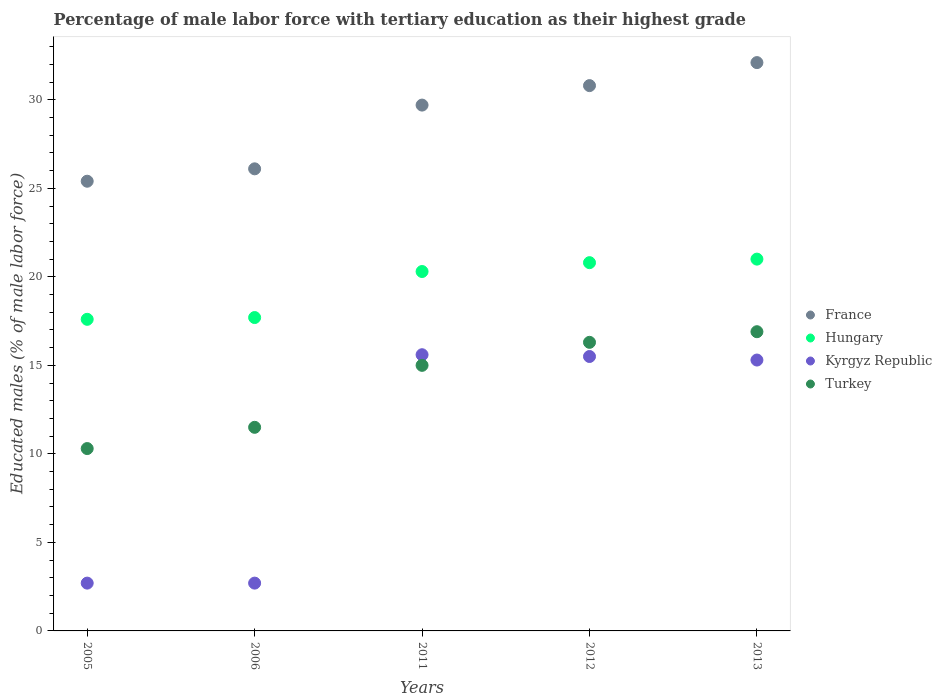What is the percentage of male labor force with tertiary education in France in 2012?
Your response must be concise. 30.8. Across all years, what is the maximum percentage of male labor force with tertiary education in Kyrgyz Republic?
Make the answer very short. 15.6. Across all years, what is the minimum percentage of male labor force with tertiary education in Turkey?
Make the answer very short. 10.3. In which year was the percentage of male labor force with tertiary education in Kyrgyz Republic maximum?
Your response must be concise. 2011. What is the total percentage of male labor force with tertiary education in Hungary in the graph?
Your answer should be very brief. 97.4. What is the difference between the percentage of male labor force with tertiary education in Hungary in 2013 and the percentage of male labor force with tertiary education in Turkey in 2005?
Ensure brevity in your answer.  10.7. What is the average percentage of male labor force with tertiary education in France per year?
Your answer should be very brief. 28.82. In the year 2005, what is the difference between the percentage of male labor force with tertiary education in Hungary and percentage of male labor force with tertiary education in France?
Your answer should be very brief. -7.8. What is the ratio of the percentage of male labor force with tertiary education in Turkey in 2005 to that in 2011?
Give a very brief answer. 0.69. What is the difference between the highest and the second highest percentage of male labor force with tertiary education in Hungary?
Ensure brevity in your answer.  0.2. What is the difference between the highest and the lowest percentage of male labor force with tertiary education in Kyrgyz Republic?
Provide a succinct answer. 12.9. In how many years, is the percentage of male labor force with tertiary education in Hungary greater than the average percentage of male labor force with tertiary education in Hungary taken over all years?
Your answer should be compact. 3. Is the sum of the percentage of male labor force with tertiary education in Kyrgyz Republic in 2005 and 2012 greater than the maximum percentage of male labor force with tertiary education in Turkey across all years?
Provide a short and direct response. Yes. Is it the case that in every year, the sum of the percentage of male labor force with tertiary education in Kyrgyz Republic and percentage of male labor force with tertiary education in Hungary  is greater than the percentage of male labor force with tertiary education in Turkey?
Keep it short and to the point. Yes. Is the percentage of male labor force with tertiary education in France strictly less than the percentage of male labor force with tertiary education in Kyrgyz Republic over the years?
Make the answer very short. No. How many years are there in the graph?
Offer a very short reply. 5. What is the difference between two consecutive major ticks on the Y-axis?
Offer a very short reply. 5. Are the values on the major ticks of Y-axis written in scientific E-notation?
Make the answer very short. No. Does the graph contain any zero values?
Your answer should be very brief. No. Does the graph contain grids?
Provide a succinct answer. No. How many legend labels are there?
Ensure brevity in your answer.  4. How are the legend labels stacked?
Provide a short and direct response. Vertical. What is the title of the graph?
Your answer should be compact. Percentage of male labor force with tertiary education as their highest grade. What is the label or title of the X-axis?
Give a very brief answer. Years. What is the label or title of the Y-axis?
Offer a very short reply. Educated males (% of male labor force). What is the Educated males (% of male labor force) in France in 2005?
Your response must be concise. 25.4. What is the Educated males (% of male labor force) of Hungary in 2005?
Offer a terse response. 17.6. What is the Educated males (% of male labor force) of Kyrgyz Republic in 2005?
Your answer should be very brief. 2.7. What is the Educated males (% of male labor force) of Turkey in 2005?
Keep it short and to the point. 10.3. What is the Educated males (% of male labor force) in France in 2006?
Make the answer very short. 26.1. What is the Educated males (% of male labor force) of Hungary in 2006?
Ensure brevity in your answer.  17.7. What is the Educated males (% of male labor force) of Kyrgyz Republic in 2006?
Make the answer very short. 2.7. What is the Educated males (% of male labor force) in France in 2011?
Ensure brevity in your answer.  29.7. What is the Educated males (% of male labor force) in Hungary in 2011?
Ensure brevity in your answer.  20.3. What is the Educated males (% of male labor force) of Kyrgyz Republic in 2011?
Ensure brevity in your answer.  15.6. What is the Educated males (% of male labor force) in France in 2012?
Provide a short and direct response. 30.8. What is the Educated males (% of male labor force) in Hungary in 2012?
Offer a terse response. 20.8. What is the Educated males (% of male labor force) of Kyrgyz Republic in 2012?
Ensure brevity in your answer.  15.5. What is the Educated males (% of male labor force) of Turkey in 2012?
Give a very brief answer. 16.3. What is the Educated males (% of male labor force) in France in 2013?
Make the answer very short. 32.1. What is the Educated males (% of male labor force) in Hungary in 2013?
Keep it short and to the point. 21. What is the Educated males (% of male labor force) of Kyrgyz Republic in 2013?
Your answer should be very brief. 15.3. What is the Educated males (% of male labor force) in Turkey in 2013?
Offer a terse response. 16.9. Across all years, what is the maximum Educated males (% of male labor force) of France?
Your answer should be compact. 32.1. Across all years, what is the maximum Educated males (% of male labor force) in Kyrgyz Republic?
Make the answer very short. 15.6. Across all years, what is the maximum Educated males (% of male labor force) in Turkey?
Give a very brief answer. 16.9. Across all years, what is the minimum Educated males (% of male labor force) in France?
Provide a succinct answer. 25.4. Across all years, what is the minimum Educated males (% of male labor force) in Hungary?
Ensure brevity in your answer.  17.6. Across all years, what is the minimum Educated males (% of male labor force) of Kyrgyz Republic?
Your answer should be very brief. 2.7. Across all years, what is the minimum Educated males (% of male labor force) in Turkey?
Give a very brief answer. 10.3. What is the total Educated males (% of male labor force) of France in the graph?
Offer a terse response. 144.1. What is the total Educated males (% of male labor force) of Hungary in the graph?
Give a very brief answer. 97.4. What is the total Educated males (% of male labor force) of Kyrgyz Republic in the graph?
Offer a very short reply. 51.8. What is the difference between the Educated males (% of male labor force) of France in 2005 and that in 2006?
Offer a very short reply. -0.7. What is the difference between the Educated males (% of male labor force) in Hungary in 2005 and that in 2006?
Your answer should be very brief. -0.1. What is the difference between the Educated males (% of male labor force) of Turkey in 2005 and that in 2006?
Ensure brevity in your answer.  -1.2. What is the difference between the Educated males (% of male labor force) of Hungary in 2005 and that in 2011?
Provide a short and direct response. -2.7. What is the difference between the Educated males (% of male labor force) in Hungary in 2005 and that in 2012?
Provide a short and direct response. -3.2. What is the difference between the Educated males (% of male labor force) in Kyrgyz Republic in 2005 and that in 2012?
Give a very brief answer. -12.8. What is the difference between the Educated males (% of male labor force) of Hungary in 2005 and that in 2013?
Give a very brief answer. -3.4. What is the difference between the Educated males (% of male labor force) of Kyrgyz Republic in 2006 and that in 2011?
Provide a short and direct response. -12.9. What is the difference between the Educated males (% of male labor force) in Turkey in 2006 and that in 2011?
Offer a terse response. -3.5. What is the difference between the Educated males (% of male labor force) of Hungary in 2006 and that in 2012?
Your answer should be compact. -3.1. What is the difference between the Educated males (% of male labor force) in Kyrgyz Republic in 2006 and that in 2012?
Offer a very short reply. -12.8. What is the difference between the Educated males (% of male labor force) of Turkey in 2006 and that in 2012?
Provide a short and direct response. -4.8. What is the difference between the Educated males (% of male labor force) in France in 2006 and that in 2013?
Your response must be concise. -6. What is the difference between the Educated males (% of male labor force) in Turkey in 2006 and that in 2013?
Your answer should be very brief. -5.4. What is the difference between the Educated males (% of male labor force) of Kyrgyz Republic in 2011 and that in 2012?
Give a very brief answer. 0.1. What is the difference between the Educated males (% of male labor force) of Kyrgyz Republic in 2011 and that in 2013?
Offer a very short reply. 0.3. What is the difference between the Educated males (% of male labor force) of France in 2012 and that in 2013?
Keep it short and to the point. -1.3. What is the difference between the Educated males (% of male labor force) of Turkey in 2012 and that in 2013?
Provide a short and direct response. -0.6. What is the difference between the Educated males (% of male labor force) of France in 2005 and the Educated males (% of male labor force) of Kyrgyz Republic in 2006?
Ensure brevity in your answer.  22.7. What is the difference between the Educated males (% of male labor force) in France in 2005 and the Educated males (% of male labor force) in Turkey in 2006?
Give a very brief answer. 13.9. What is the difference between the Educated males (% of male labor force) in Hungary in 2005 and the Educated males (% of male labor force) in Kyrgyz Republic in 2006?
Provide a short and direct response. 14.9. What is the difference between the Educated males (% of male labor force) in Kyrgyz Republic in 2005 and the Educated males (% of male labor force) in Turkey in 2006?
Offer a very short reply. -8.8. What is the difference between the Educated males (% of male labor force) of France in 2005 and the Educated males (% of male labor force) of Hungary in 2011?
Offer a terse response. 5.1. What is the difference between the Educated males (% of male labor force) of France in 2005 and the Educated males (% of male labor force) of Kyrgyz Republic in 2011?
Keep it short and to the point. 9.8. What is the difference between the Educated males (% of male labor force) of France in 2005 and the Educated males (% of male labor force) of Turkey in 2011?
Offer a terse response. 10.4. What is the difference between the Educated males (% of male labor force) of Hungary in 2005 and the Educated males (% of male labor force) of Kyrgyz Republic in 2011?
Ensure brevity in your answer.  2. What is the difference between the Educated males (% of male labor force) of Kyrgyz Republic in 2005 and the Educated males (% of male labor force) of Turkey in 2011?
Your answer should be very brief. -12.3. What is the difference between the Educated males (% of male labor force) of France in 2005 and the Educated males (% of male labor force) of Hungary in 2012?
Offer a terse response. 4.6. What is the difference between the Educated males (% of male labor force) in Hungary in 2005 and the Educated males (% of male labor force) in Kyrgyz Republic in 2012?
Provide a succinct answer. 2.1. What is the difference between the Educated males (% of male labor force) in Kyrgyz Republic in 2005 and the Educated males (% of male labor force) in Turkey in 2012?
Make the answer very short. -13.6. What is the difference between the Educated males (% of male labor force) of Hungary in 2005 and the Educated males (% of male labor force) of Kyrgyz Republic in 2013?
Offer a very short reply. 2.3. What is the difference between the Educated males (% of male labor force) of Hungary in 2005 and the Educated males (% of male labor force) of Turkey in 2013?
Provide a short and direct response. 0.7. What is the difference between the Educated males (% of male labor force) of France in 2006 and the Educated males (% of male labor force) of Kyrgyz Republic in 2011?
Offer a terse response. 10.5. What is the difference between the Educated males (% of male labor force) in Hungary in 2006 and the Educated males (% of male labor force) in Kyrgyz Republic in 2011?
Your answer should be compact. 2.1. What is the difference between the Educated males (% of male labor force) of Kyrgyz Republic in 2006 and the Educated males (% of male labor force) of Turkey in 2011?
Ensure brevity in your answer.  -12.3. What is the difference between the Educated males (% of male labor force) of France in 2006 and the Educated males (% of male labor force) of Kyrgyz Republic in 2012?
Make the answer very short. 10.6. What is the difference between the Educated males (% of male labor force) of Hungary in 2006 and the Educated males (% of male labor force) of Kyrgyz Republic in 2012?
Your answer should be compact. 2.2. What is the difference between the Educated males (% of male labor force) in Hungary in 2006 and the Educated males (% of male labor force) in Turkey in 2012?
Make the answer very short. 1.4. What is the difference between the Educated males (% of male labor force) of Kyrgyz Republic in 2006 and the Educated males (% of male labor force) of Turkey in 2012?
Your answer should be very brief. -13.6. What is the difference between the Educated males (% of male labor force) in France in 2006 and the Educated males (% of male labor force) in Hungary in 2013?
Your response must be concise. 5.1. What is the difference between the Educated males (% of male labor force) of France in 2006 and the Educated males (% of male labor force) of Kyrgyz Republic in 2013?
Your response must be concise. 10.8. What is the difference between the Educated males (% of male labor force) in France in 2006 and the Educated males (% of male labor force) in Turkey in 2013?
Provide a short and direct response. 9.2. What is the difference between the Educated males (% of male labor force) in Hungary in 2006 and the Educated males (% of male labor force) in Turkey in 2013?
Keep it short and to the point. 0.8. What is the difference between the Educated males (% of male labor force) of France in 2011 and the Educated males (% of male labor force) of Hungary in 2012?
Offer a terse response. 8.9. What is the difference between the Educated males (% of male labor force) of France in 2011 and the Educated males (% of male labor force) of Kyrgyz Republic in 2013?
Keep it short and to the point. 14.4. What is the difference between the Educated males (% of male labor force) of France in 2011 and the Educated males (% of male labor force) of Turkey in 2013?
Give a very brief answer. 12.8. What is the difference between the Educated males (% of male labor force) in Hungary in 2011 and the Educated males (% of male labor force) in Kyrgyz Republic in 2013?
Your response must be concise. 5. What is the difference between the Educated males (% of male labor force) in France in 2012 and the Educated males (% of male labor force) in Hungary in 2013?
Keep it short and to the point. 9.8. What is the difference between the Educated males (% of male labor force) in France in 2012 and the Educated males (% of male labor force) in Kyrgyz Republic in 2013?
Ensure brevity in your answer.  15.5. What is the average Educated males (% of male labor force) in France per year?
Your answer should be very brief. 28.82. What is the average Educated males (% of male labor force) in Hungary per year?
Give a very brief answer. 19.48. What is the average Educated males (% of male labor force) of Kyrgyz Republic per year?
Provide a succinct answer. 10.36. What is the average Educated males (% of male labor force) of Turkey per year?
Your answer should be very brief. 14. In the year 2005, what is the difference between the Educated males (% of male labor force) in France and Educated males (% of male labor force) in Hungary?
Ensure brevity in your answer.  7.8. In the year 2005, what is the difference between the Educated males (% of male labor force) of France and Educated males (% of male labor force) of Kyrgyz Republic?
Provide a succinct answer. 22.7. In the year 2005, what is the difference between the Educated males (% of male labor force) of Hungary and Educated males (% of male labor force) of Kyrgyz Republic?
Make the answer very short. 14.9. In the year 2006, what is the difference between the Educated males (% of male labor force) in France and Educated males (% of male labor force) in Hungary?
Offer a terse response. 8.4. In the year 2006, what is the difference between the Educated males (% of male labor force) of France and Educated males (% of male labor force) of Kyrgyz Republic?
Provide a succinct answer. 23.4. In the year 2006, what is the difference between the Educated males (% of male labor force) of France and Educated males (% of male labor force) of Turkey?
Your answer should be compact. 14.6. In the year 2006, what is the difference between the Educated males (% of male labor force) of Hungary and Educated males (% of male labor force) of Turkey?
Provide a succinct answer. 6.2. In the year 2011, what is the difference between the Educated males (% of male labor force) of France and Educated males (% of male labor force) of Turkey?
Provide a succinct answer. 14.7. In the year 2011, what is the difference between the Educated males (% of male labor force) in Hungary and Educated males (% of male labor force) in Kyrgyz Republic?
Offer a very short reply. 4.7. In the year 2011, what is the difference between the Educated males (% of male labor force) in Hungary and Educated males (% of male labor force) in Turkey?
Offer a terse response. 5.3. In the year 2011, what is the difference between the Educated males (% of male labor force) in Kyrgyz Republic and Educated males (% of male labor force) in Turkey?
Your response must be concise. 0.6. In the year 2012, what is the difference between the Educated males (% of male labor force) of France and Educated males (% of male labor force) of Hungary?
Give a very brief answer. 10. In the year 2012, what is the difference between the Educated males (% of male labor force) of Hungary and Educated males (% of male labor force) of Kyrgyz Republic?
Offer a very short reply. 5.3. In the year 2012, what is the difference between the Educated males (% of male labor force) of Kyrgyz Republic and Educated males (% of male labor force) of Turkey?
Your response must be concise. -0.8. In the year 2013, what is the difference between the Educated males (% of male labor force) of Kyrgyz Republic and Educated males (% of male labor force) of Turkey?
Provide a succinct answer. -1.6. What is the ratio of the Educated males (% of male labor force) in France in 2005 to that in 2006?
Keep it short and to the point. 0.97. What is the ratio of the Educated males (% of male labor force) in Turkey in 2005 to that in 2006?
Ensure brevity in your answer.  0.9. What is the ratio of the Educated males (% of male labor force) in France in 2005 to that in 2011?
Your answer should be compact. 0.86. What is the ratio of the Educated males (% of male labor force) in Hungary in 2005 to that in 2011?
Provide a short and direct response. 0.87. What is the ratio of the Educated males (% of male labor force) of Kyrgyz Republic in 2005 to that in 2011?
Provide a short and direct response. 0.17. What is the ratio of the Educated males (% of male labor force) in Turkey in 2005 to that in 2011?
Offer a very short reply. 0.69. What is the ratio of the Educated males (% of male labor force) in France in 2005 to that in 2012?
Make the answer very short. 0.82. What is the ratio of the Educated males (% of male labor force) of Hungary in 2005 to that in 2012?
Provide a succinct answer. 0.85. What is the ratio of the Educated males (% of male labor force) in Kyrgyz Republic in 2005 to that in 2012?
Your response must be concise. 0.17. What is the ratio of the Educated males (% of male labor force) in Turkey in 2005 to that in 2012?
Your answer should be very brief. 0.63. What is the ratio of the Educated males (% of male labor force) in France in 2005 to that in 2013?
Offer a terse response. 0.79. What is the ratio of the Educated males (% of male labor force) in Hungary in 2005 to that in 2013?
Make the answer very short. 0.84. What is the ratio of the Educated males (% of male labor force) of Kyrgyz Republic in 2005 to that in 2013?
Keep it short and to the point. 0.18. What is the ratio of the Educated males (% of male labor force) of Turkey in 2005 to that in 2013?
Your answer should be very brief. 0.61. What is the ratio of the Educated males (% of male labor force) of France in 2006 to that in 2011?
Offer a very short reply. 0.88. What is the ratio of the Educated males (% of male labor force) in Hungary in 2006 to that in 2011?
Your response must be concise. 0.87. What is the ratio of the Educated males (% of male labor force) of Kyrgyz Republic in 2006 to that in 2011?
Keep it short and to the point. 0.17. What is the ratio of the Educated males (% of male labor force) of Turkey in 2006 to that in 2011?
Offer a terse response. 0.77. What is the ratio of the Educated males (% of male labor force) in France in 2006 to that in 2012?
Your answer should be very brief. 0.85. What is the ratio of the Educated males (% of male labor force) of Hungary in 2006 to that in 2012?
Your answer should be compact. 0.85. What is the ratio of the Educated males (% of male labor force) in Kyrgyz Republic in 2006 to that in 2012?
Give a very brief answer. 0.17. What is the ratio of the Educated males (% of male labor force) of Turkey in 2006 to that in 2012?
Provide a succinct answer. 0.71. What is the ratio of the Educated males (% of male labor force) of France in 2006 to that in 2013?
Ensure brevity in your answer.  0.81. What is the ratio of the Educated males (% of male labor force) of Hungary in 2006 to that in 2013?
Make the answer very short. 0.84. What is the ratio of the Educated males (% of male labor force) of Kyrgyz Republic in 2006 to that in 2013?
Keep it short and to the point. 0.18. What is the ratio of the Educated males (% of male labor force) of Turkey in 2006 to that in 2013?
Ensure brevity in your answer.  0.68. What is the ratio of the Educated males (% of male labor force) of France in 2011 to that in 2012?
Give a very brief answer. 0.96. What is the ratio of the Educated males (% of male labor force) in Hungary in 2011 to that in 2012?
Your answer should be compact. 0.98. What is the ratio of the Educated males (% of male labor force) in Kyrgyz Republic in 2011 to that in 2012?
Give a very brief answer. 1.01. What is the ratio of the Educated males (% of male labor force) in Turkey in 2011 to that in 2012?
Provide a short and direct response. 0.92. What is the ratio of the Educated males (% of male labor force) of France in 2011 to that in 2013?
Give a very brief answer. 0.93. What is the ratio of the Educated males (% of male labor force) in Hungary in 2011 to that in 2013?
Your response must be concise. 0.97. What is the ratio of the Educated males (% of male labor force) of Kyrgyz Republic in 2011 to that in 2013?
Your answer should be compact. 1.02. What is the ratio of the Educated males (% of male labor force) in Turkey in 2011 to that in 2013?
Your answer should be very brief. 0.89. What is the ratio of the Educated males (% of male labor force) of France in 2012 to that in 2013?
Keep it short and to the point. 0.96. What is the ratio of the Educated males (% of male labor force) of Hungary in 2012 to that in 2013?
Offer a very short reply. 0.99. What is the ratio of the Educated males (% of male labor force) of Kyrgyz Republic in 2012 to that in 2013?
Make the answer very short. 1.01. What is the ratio of the Educated males (% of male labor force) of Turkey in 2012 to that in 2013?
Your answer should be compact. 0.96. What is the difference between the highest and the second highest Educated males (% of male labor force) of France?
Offer a very short reply. 1.3. What is the difference between the highest and the lowest Educated males (% of male labor force) of Hungary?
Keep it short and to the point. 3.4. What is the difference between the highest and the lowest Educated males (% of male labor force) of Turkey?
Provide a short and direct response. 6.6. 